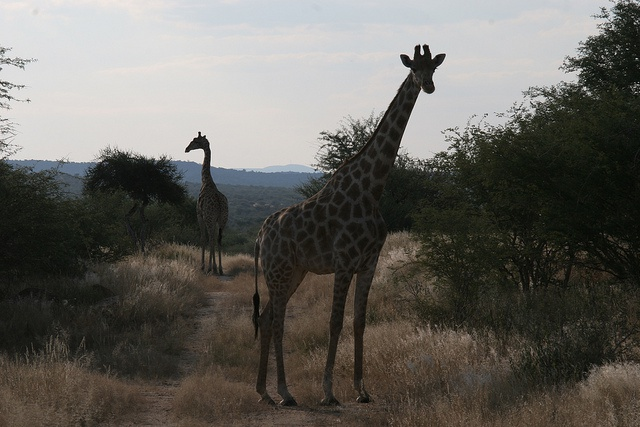Describe the objects in this image and their specific colors. I can see giraffe in lightgray, black, and gray tones and giraffe in lightgray, black, and gray tones in this image. 